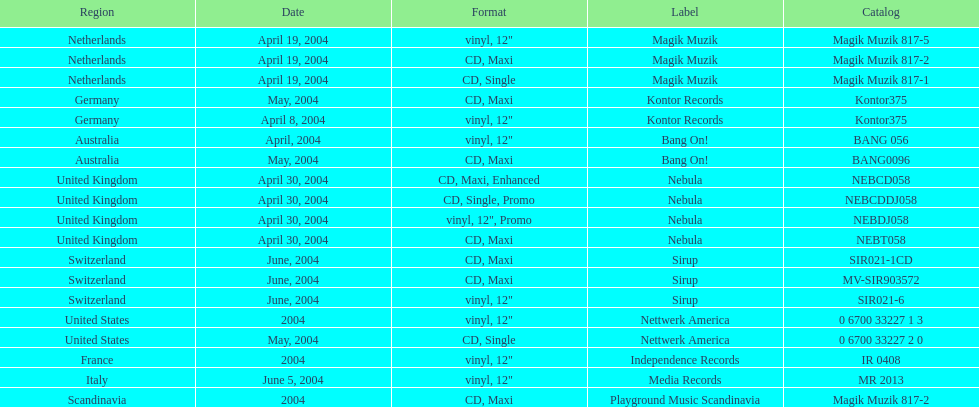What label was the only label to be used by france? Independence Records. 